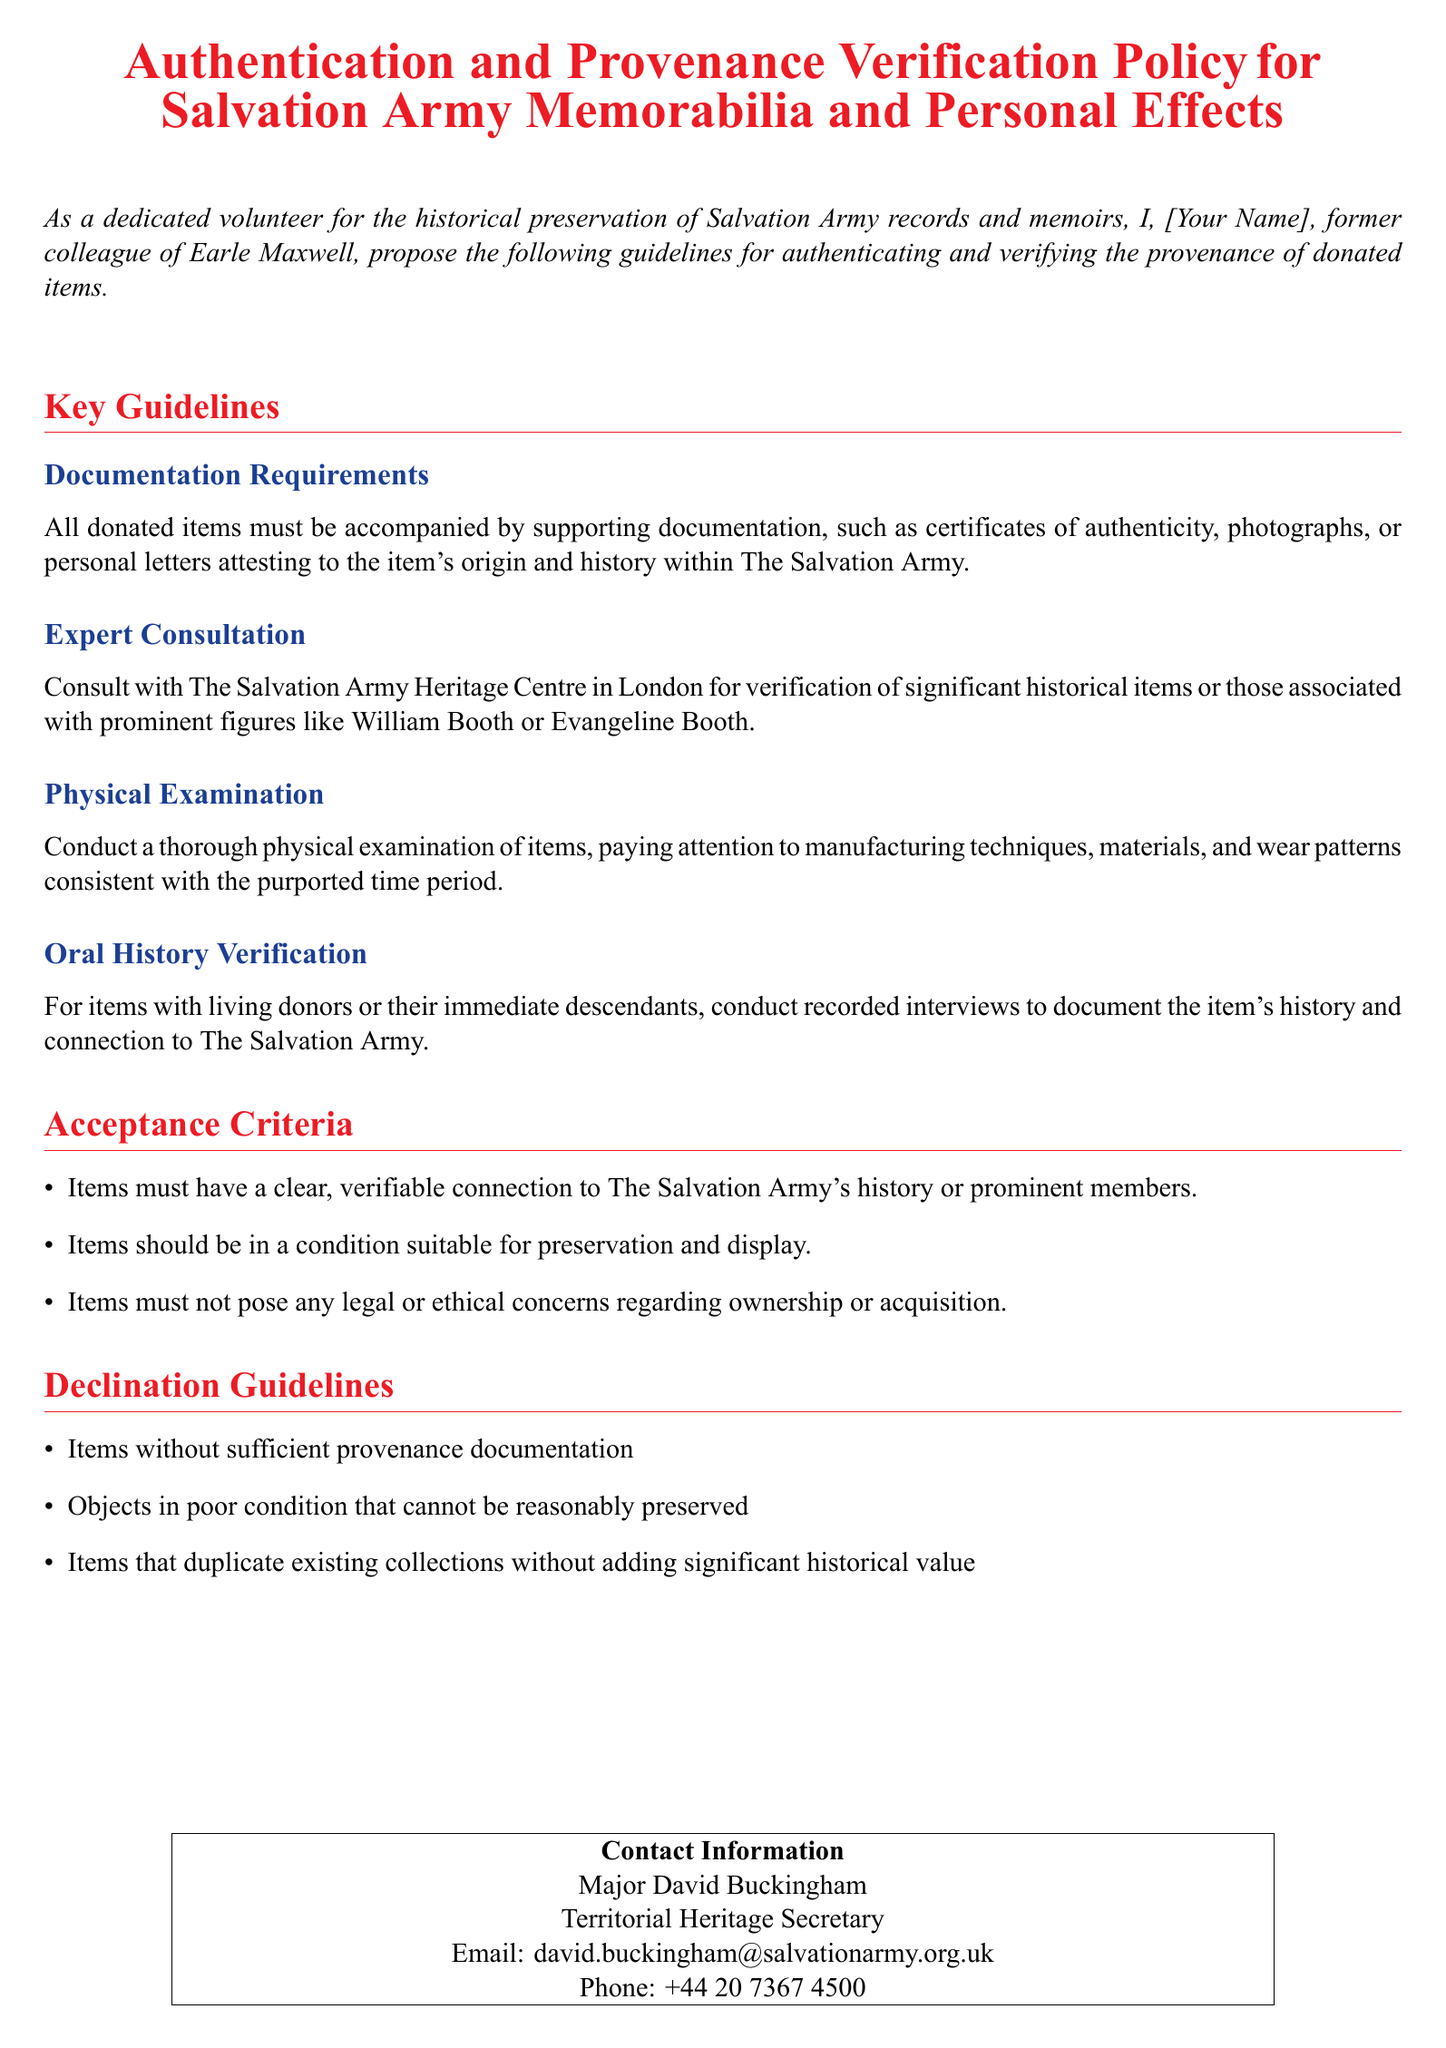What is the title of the document? The title is prominently featured at the top of the document and is "Authentication and Provenance Verification Policy for Salvation Army Memorabilia and Personal Effects."
Answer: Authentication and Provenance Verification Policy for Salvation Army Memorabilia and Personal Effects Who proposed the guidelines? The author of the guidelines is mentioned at the beginning where they introduce themselves as a dedicated volunteer and former colleague of Earle Maxwell.
Answer: [Your Name] What must accompany all donated items? The document specifies that all donated items must have supporting documentation like certificates of authenticity, photographs, or personal letters.
Answer: Supporting documentation Where can significant historical items be verified? The document suggests consulting with a specific center for verification, which is The Salvation Army Heritage Centre in London.
Answer: The Salvation Army Heritage Centre in London What type of examination should be performed on items? The document mentions that a thorough physical examination of items should be conducted.
Answer: Thorough physical examination What are items required to have to be accepted? It specifies that items must have a clear, verifiable connection to The Salvation Army's history or prominent members.
Answer: Clear, verifiable connection What should be done for items with living donors? The document states that recorded interviews should be conducted with living donors or their immediate descendants.
Answer: Recorded interviews What is one reason an item might be declined? The document outlines several reasons, one of which is items without sufficient provenance documentation.
Answer: Insufficient provenance documentation Who is the contact person for this policy? The contact information section lists Major David Buckingham as the person to contact.
Answer: Major David Buckingham 